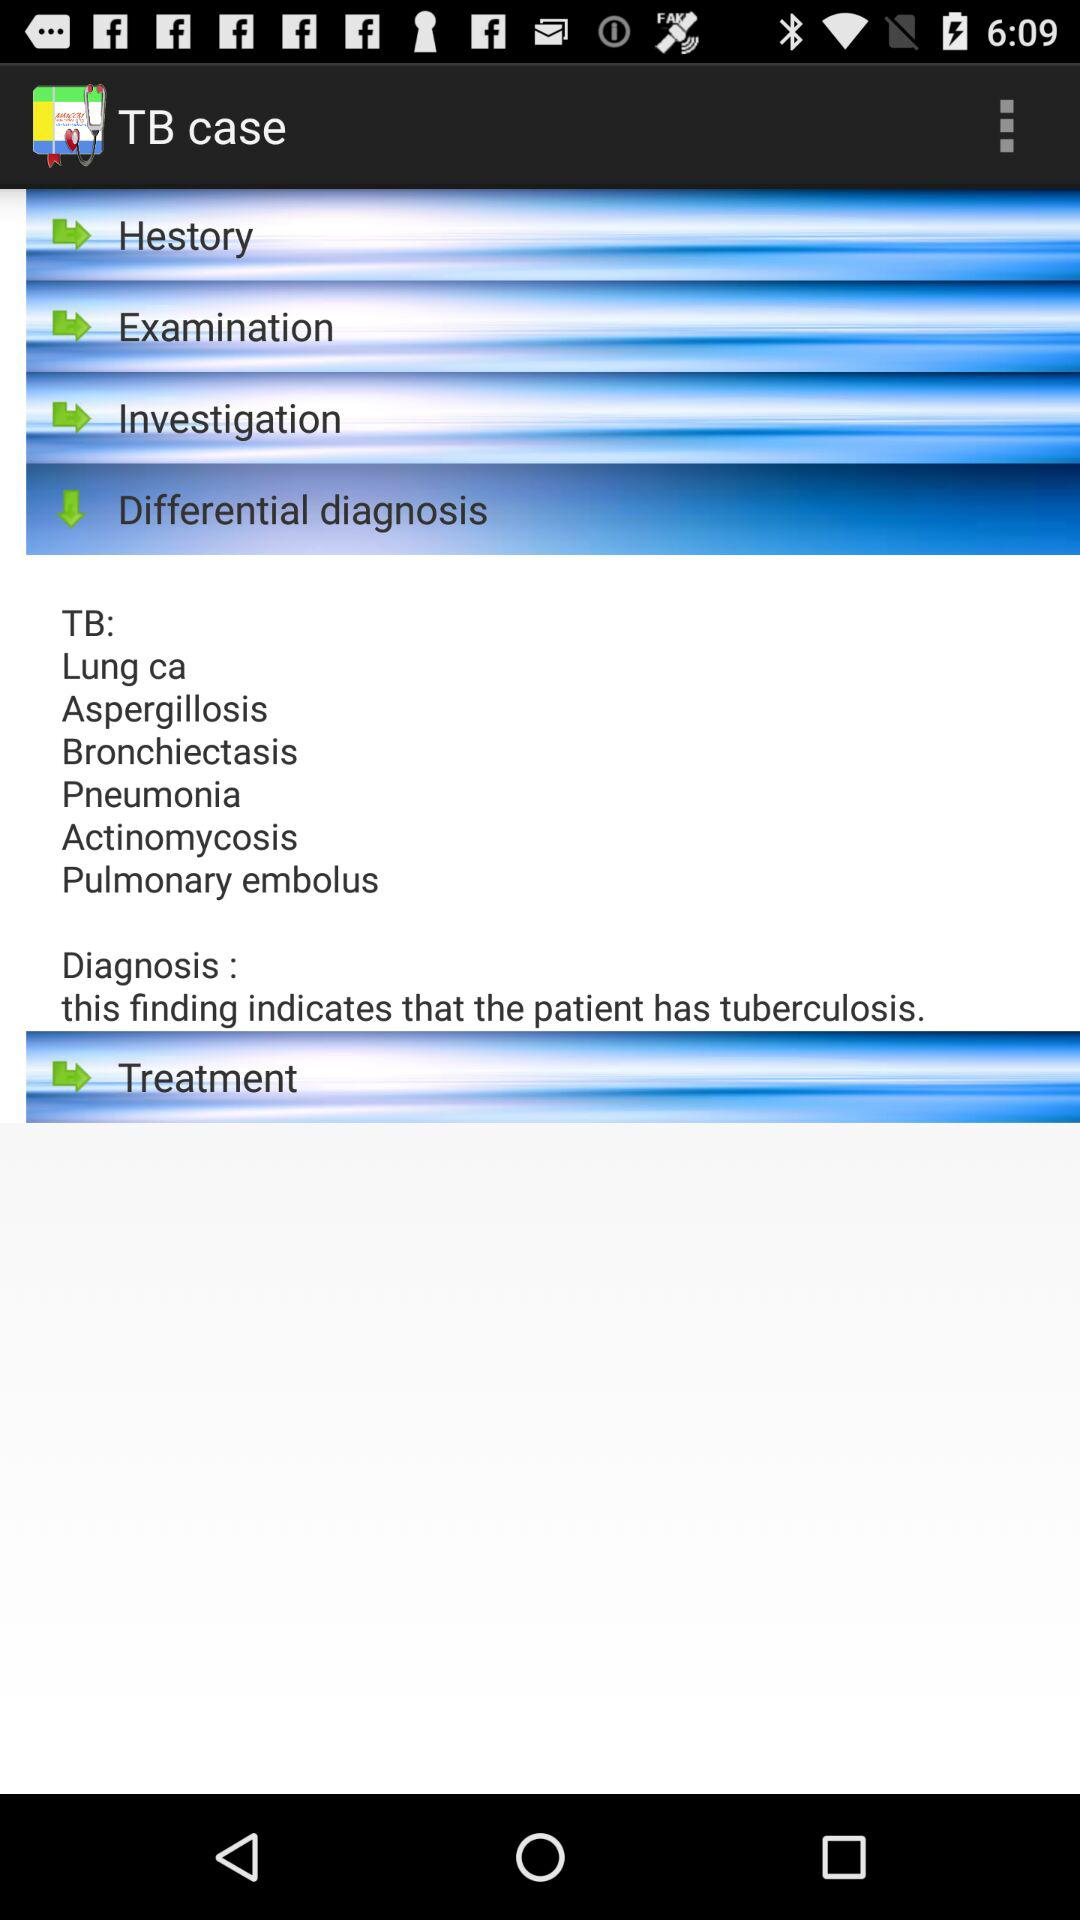How will the treatment be conducted?
When the provided information is insufficient, respond with <no answer>. <no answer> 